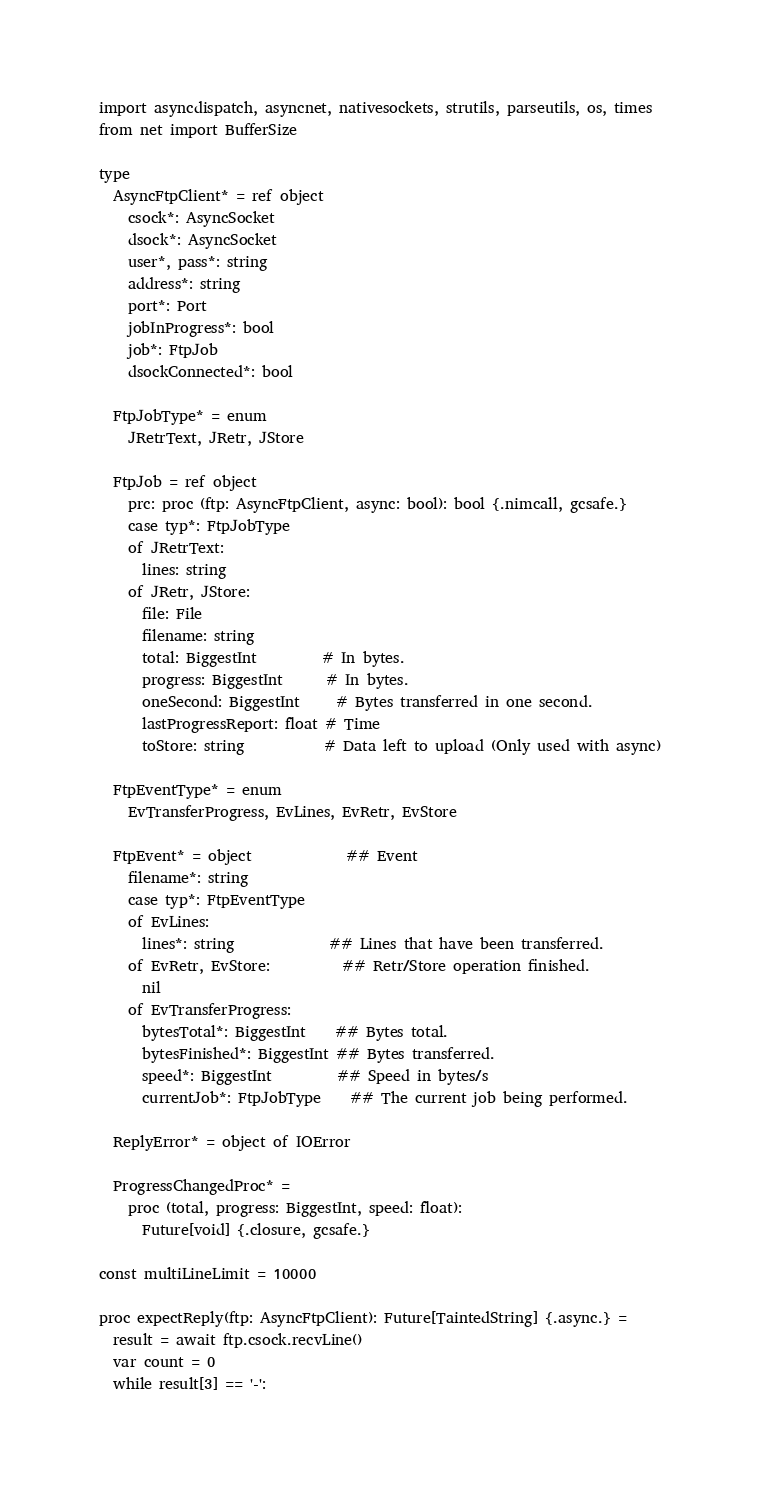<code> <loc_0><loc_0><loc_500><loc_500><_Nim_>

import asyncdispatch, asyncnet, nativesockets, strutils, parseutils, os, times
from net import BufferSize

type
  AsyncFtpClient* = ref object
    csock*: AsyncSocket
    dsock*: AsyncSocket
    user*, pass*: string
    address*: string
    port*: Port
    jobInProgress*: bool
    job*: FtpJob
    dsockConnected*: bool

  FtpJobType* = enum
    JRetrText, JRetr, JStore

  FtpJob = ref object
    prc: proc (ftp: AsyncFtpClient, async: bool): bool {.nimcall, gcsafe.}
    case typ*: FtpJobType
    of JRetrText:
      lines: string
    of JRetr, JStore:
      file: File
      filename: string
      total: BiggestInt         # In bytes.
      progress: BiggestInt      # In bytes.
      oneSecond: BiggestInt     # Bytes transferred in one second.
      lastProgressReport: float # Time
      toStore: string           # Data left to upload (Only used with async)

  FtpEventType* = enum
    EvTransferProgress, EvLines, EvRetr, EvStore

  FtpEvent* = object             ## Event
    filename*: string
    case typ*: FtpEventType
    of EvLines:
      lines*: string             ## Lines that have been transferred.
    of EvRetr, EvStore:          ## Retr/Store operation finished.
      nil
    of EvTransferProgress:
      bytesTotal*: BiggestInt    ## Bytes total.
      bytesFinished*: BiggestInt ## Bytes transferred.
      speed*: BiggestInt         ## Speed in bytes/s
      currentJob*: FtpJobType    ## The current job being performed.

  ReplyError* = object of IOError

  ProgressChangedProc* =
    proc (total, progress: BiggestInt, speed: float):
      Future[void] {.closure, gcsafe.}

const multiLineLimit = 10000

proc expectReply(ftp: AsyncFtpClient): Future[TaintedString] {.async.} =
  result = await ftp.csock.recvLine()
  var count = 0
  while result[3] == '-':</code> 